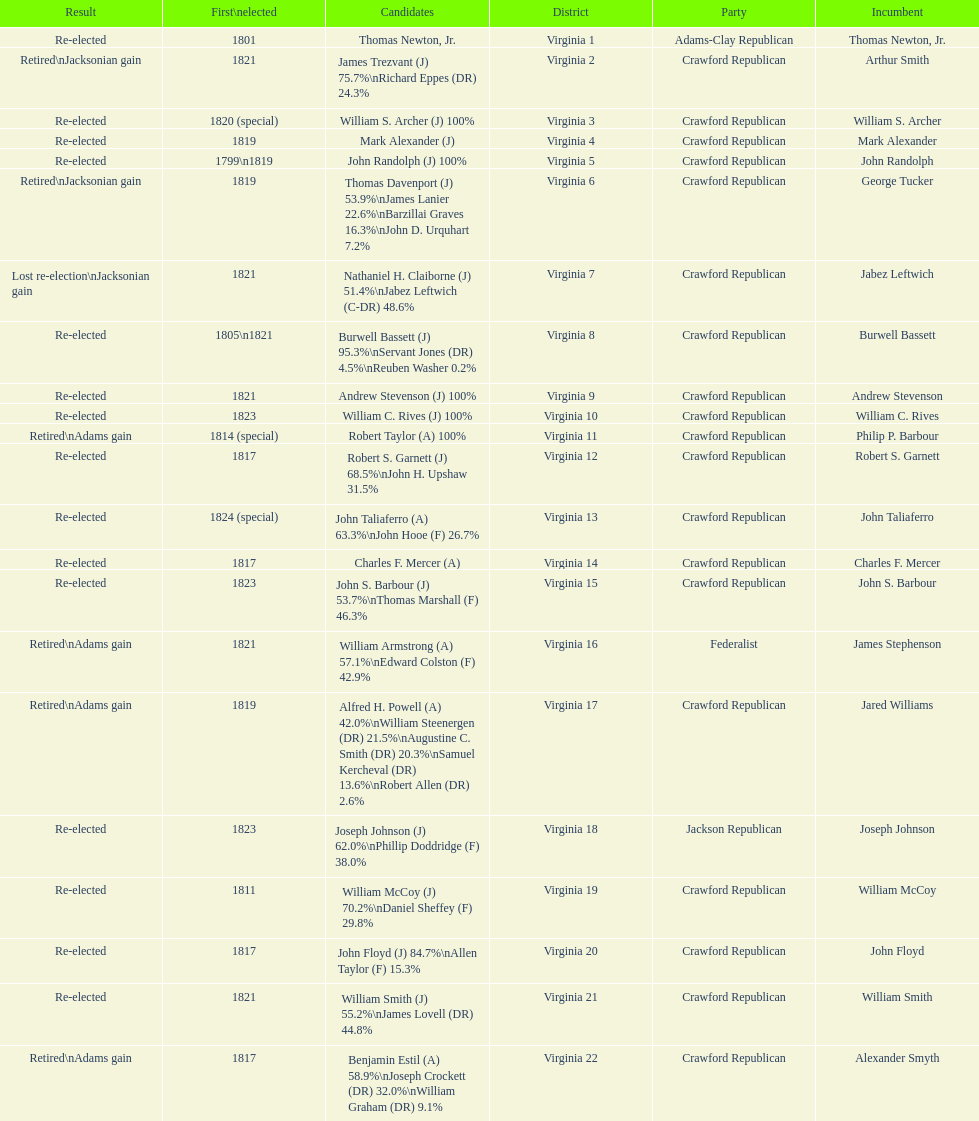What is the last party on this chart? Crawford Republican. 